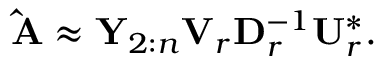Convert formula to latex. <formula><loc_0><loc_0><loc_500><loc_500>\begin{array} { r } { \hat { A } \approx Y _ { 2 \colon n } V _ { r } D _ { r } ^ { - 1 } U _ { r } ^ { * } . } \end{array}</formula> 